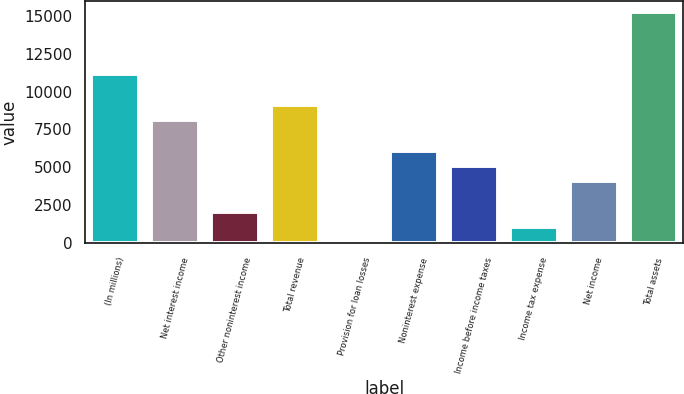Convert chart to OTSL. <chart><loc_0><loc_0><loc_500><loc_500><bar_chart><fcel>(In millions)<fcel>Net interest income<fcel>Other noninterest income<fcel>Total revenue<fcel>Provision for loan losses<fcel>Noninterest expense<fcel>Income before income taxes<fcel>Income tax expense<fcel>Net income<fcel>Total assets<nl><fcel>11168.2<fcel>8131.5<fcel>2058<fcel>9143.75<fcel>33.5<fcel>6107<fcel>5094.75<fcel>1045.75<fcel>4082.5<fcel>15217.2<nl></chart> 